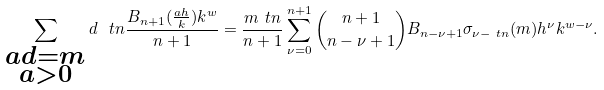Convert formula to latex. <formula><loc_0><loc_0><loc_500><loc_500>\sum _ { \substack { a d = m \\ a > 0 } } d ^ { \ } t n \frac { B _ { n + 1 } ( \frac { a h } { k } ) k ^ { w } } { n + 1 } & = \frac { m ^ { \ } t n } { n + 1 } \sum _ { \nu = 0 } ^ { n + 1 } \binom { n + 1 } { n - \nu + 1 } B _ { n - \nu + 1 } \sigma _ { \nu - \ t n } ( m ) h ^ { \nu } k ^ { w - \nu } . \\</formula> 